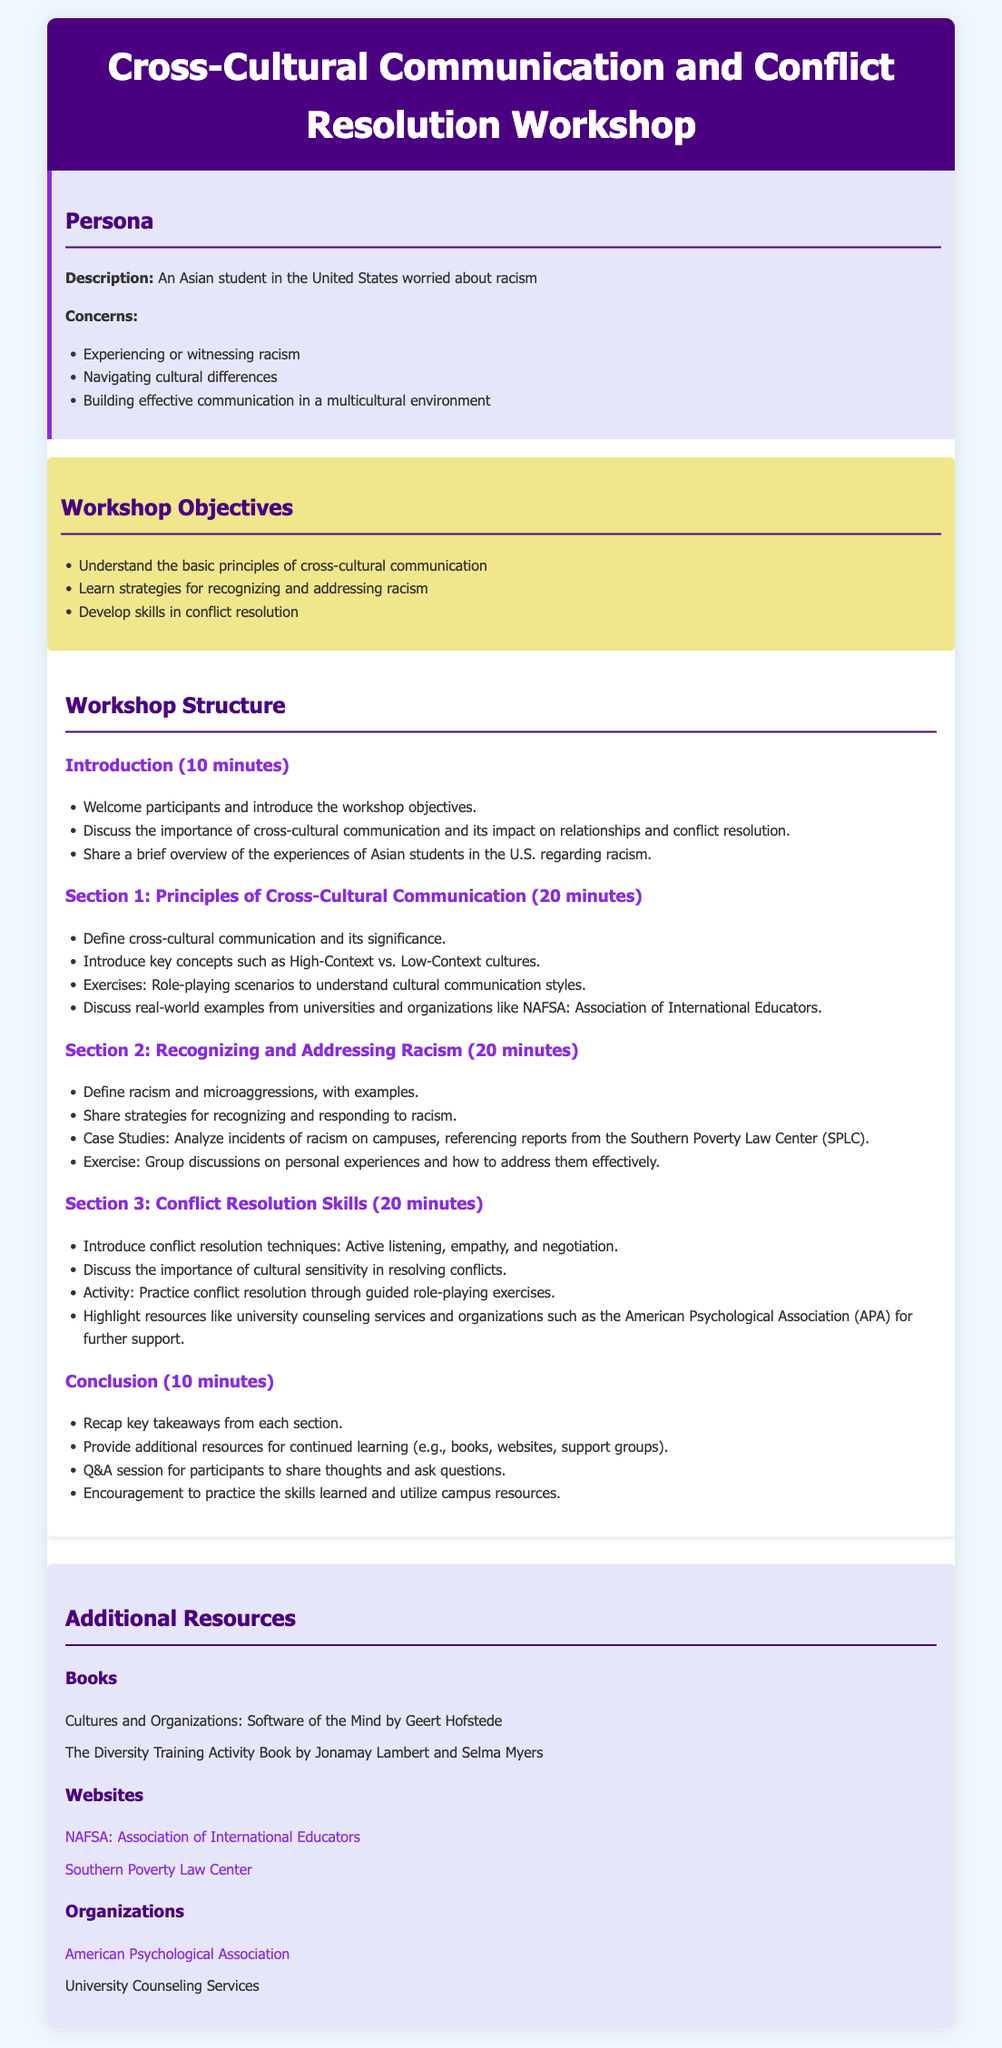What is the title of the workshop? The title is found in the header section of the document.
Answer: Cross-Cultural Communication and Conflict Resolution Workshop What is one of the objectives of the workshop? Objectives are listed in the objectives section of the document.
Answer: Understand the basic principles of cross-cultural communication How long is the introduction section? The duration of the introduction section is stated within the workshop structure.
Answer: 10 minutes Which organization is referenced for real-world examples in Section 1? The organization's name is mentioned in the overview of Section 1 in the document.
Answer: NAFSA: Association of International Educators What is a key technique introduced in Section 3? Techniques covered in Section 3 are listed in the subsection.
Answer: Active listening What type of exercises are included in the workshop? The types of exercises are mentioned throughout the workshop structure.
Answer: Role-playing scenarios How many minutes are allocated to Section 2? The allocated time for each section is specified in the workshop structure.
Answer: 20 minutes What is one resource type listed in the additional resources section? The resource types are categorized in the additional resources section of the document.
Answer: Books 